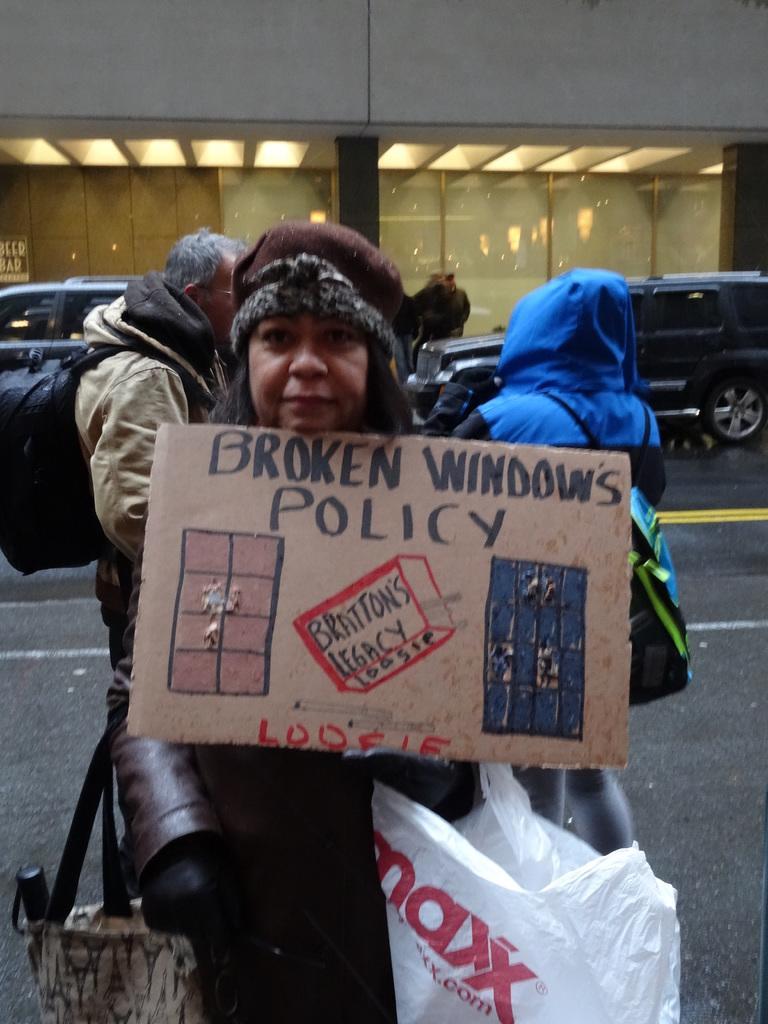Describe this image in one or two sentences. In the center of the image, we can see a lady wearing a cap, coat and a bag and holding a board and a cover. In the background, there are some other people and wearing coats and bags and there are vehicles on the road and we can see some lights, aboard, pillars and a wall. 